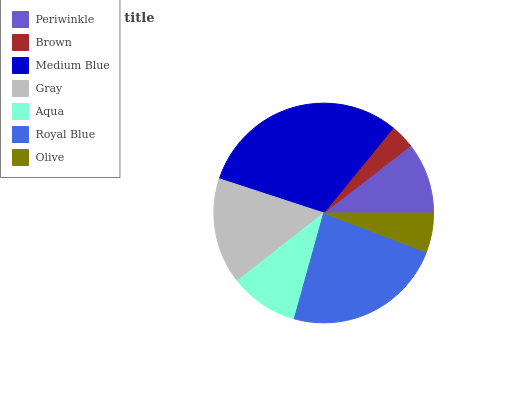Is Brown the minimum?
Answer yes or no. Yes. Is Medium Blue the maximum?
Answer yes or no. Yes. Is Medium Blue the minimum?
Answer yes or no. No. Is Brown the maximum?
Answer yes or no. No. Is Medium Blue greater than Brown?
Answer yes or no. Yes. Is Brown less than Medium Blue?
Answer yes or no. Yes. Is Brown greater than Medium Blue?
Answer yes or no. No. Is Medium Blue less than Brown?
Answer yes or no. No. Is Periwinkle the high median?
Answer yes or no. Yes. Is Periwinkle the low median?
Answer yes or no. Yes. Is Gray the high median?
Answer yes or no. No. Is Olive the low median?
Answer yes or no. No. 